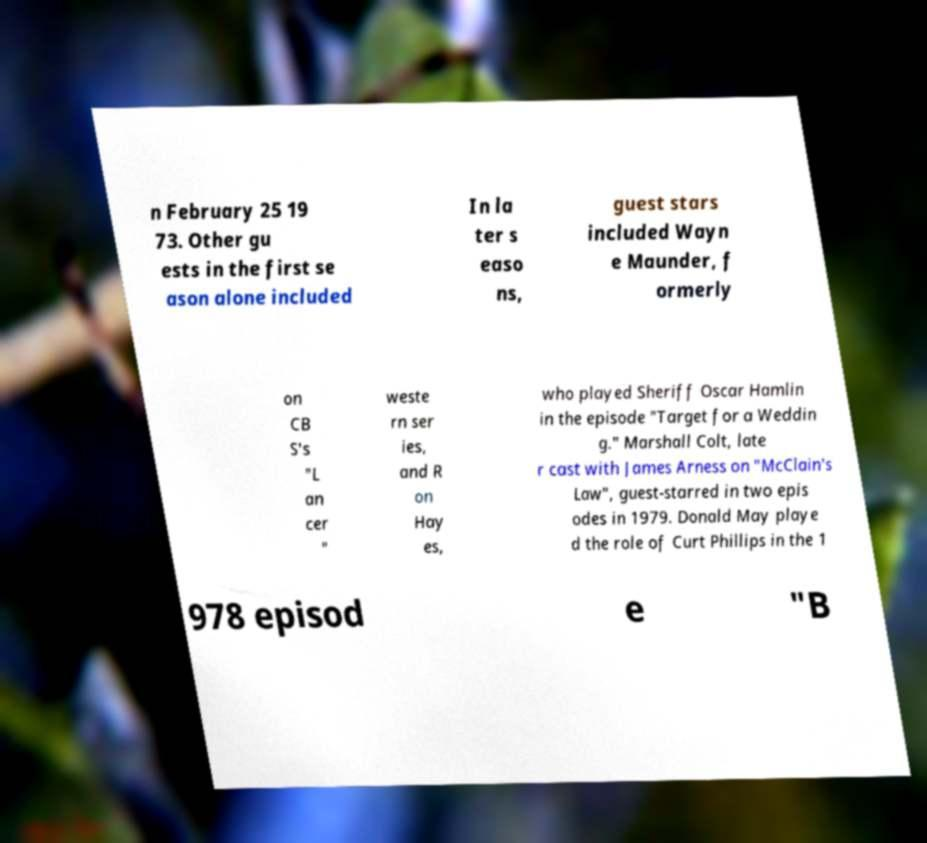What messages or text are displayed in this image? I need them in a readable, typed format. n February 25 19 73. Other gu ests in the first se ason alone included In la ter s easo ns, guest stars included Wayn e Maunder, f ormerly on CB S's "L an cer " weste rn ser ies, and R on Hay es, who played Sheriff Oscar Hamlin in the episode "Target for a Weddin g." Marshall Colt, late r cast with James Arness on "McClain's Law", guest-starred in two epis odes in 1979. Donald May playe d the role of Curt Phillips in the 1 978 episod e "B 